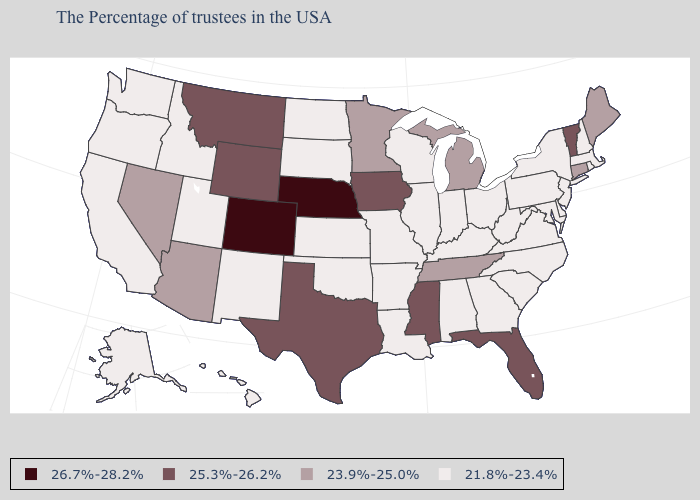Name the states that have a value in the range 21.8%-23.4%?
Concise answer only. Massachusetts, Rhode Island, New Hampshire, New York, New Jersey, Delaware, Maryland, Pennsylvania, Virginia, North Carolina, South Carolina, West Virginia, Ohio, Georgia, Kentucky, Indiana, Alabama, Wisconsin, Illinois, Louisiana, Missouri, Arkansas, Kansas, Oklahoma, South Dakota, North Dakota, New Mexico, Utah, Idaho, California, Washington, Oregon, Alaska, Hawaii. Name the states that have a value in the range 23.9%-25.0%?
Be succinct. Maine, Connecticut, Michigan, Tennessee, Minnesota, Arizona, Nevada. What is the value of Massachusetts?
Answer briefly. 21.8%-23.4%. Does Utah have the highest value in the USA?
Write a very short answer. No. What is the value of Missouri?
Concise answer only. 21.8%-23.4%. What is the value of Delaware?
Write a very short answer. 21.8%-23.4%. Name the states that have a value in the range 21.8%-23.4%?
Short answer required. Massachusetts, Rhode Island, New Hampshire, New York, New Jersey, Delaware, Maryland, Pennsylvania, Virginia, North Carolina, South Carolina, West Virginia, Ohio, Georgia, Kentucky, Indiana, Alabama, Wisconsin, Illinois, Louisiana, Missouri, Arkansas, Kansas, Oklahoma, South Dakota, North Dakota, New Mexico, Utah, Idaho, California, Washington, Oregon, Alaska, Hawaii. What is the value of Florida?
Concise answer only. 25.3%-26.2%. Does the first symbol in the legend represent the smallest category?
Answer briefly. No. Does North Dakota have a higher value than Delaware?
Short answer required. No. What is the lowest value in the MidWest?
Be succinct. 21.8%-23.4%. What is the value of South Dakota?
Keep it brief. 21.8%-23.4%. What is the value of Connecticut?
Keep it brief. 23.9%-25.0%. Name the states that have a value in the range 25.3%-26.2%?
Give a very brief answer. Vermont, Florida, Mississippi, Iowa, Texas, Wyoming, Montana. What is the lowest value in the Northeast?
Quick response, please. 21.8%-23.4%. 